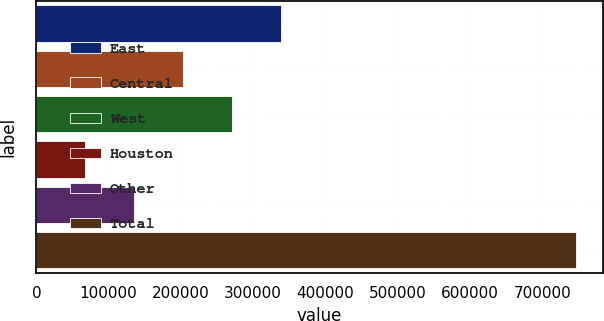Convert chart. <chart><loc_0><loc_0><loc_500><loc_500><bar_chart><fcel>East<fcel>Central<fcel>West<fcel>Houston<fcel>Other<fcel>Total<nl><fcel>339052<fcel>203230<fcel>271141<fcel>67408<fcel>135319<fcel>746518<nl></chart> 